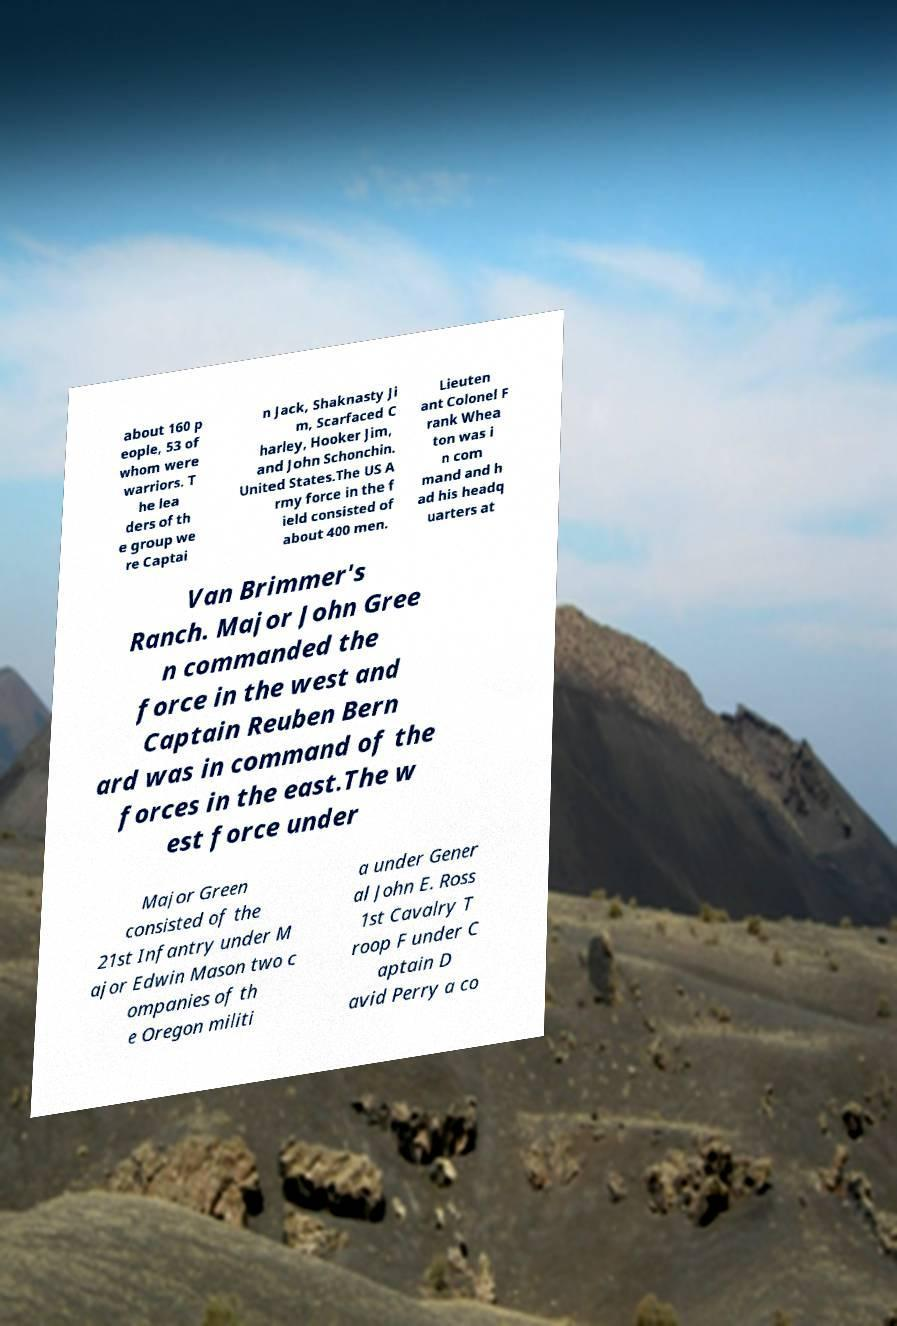For documentation purposes, I need the text within this image transcribed. Could you provide that? about 160 p eople, 53 of whom were warriors. T he lea ders of th e group we re Captai n Jack, Shaknasty Ji m, Scarfaced C harley, Hooker Jim, and John Schonchin. United States.The US A rmy force in the f ield consisted of about 400 men. Lieuten ant Colonel F rank Whea ton was i n com mand and h ad his headq uarters at Van Brimmer's Ranch. Major John Gree n commanded the force in the west and Captain Reuben Bern ard was in command of the forces in the east.The w est force under Major Green consisted of the 21st Infantry under M ajor Edwin Mason two c ompanies of th e Oregon militi a under Gener al John E. Ross 1st Cavalry T roop F under C aptain D avid Perry a co 